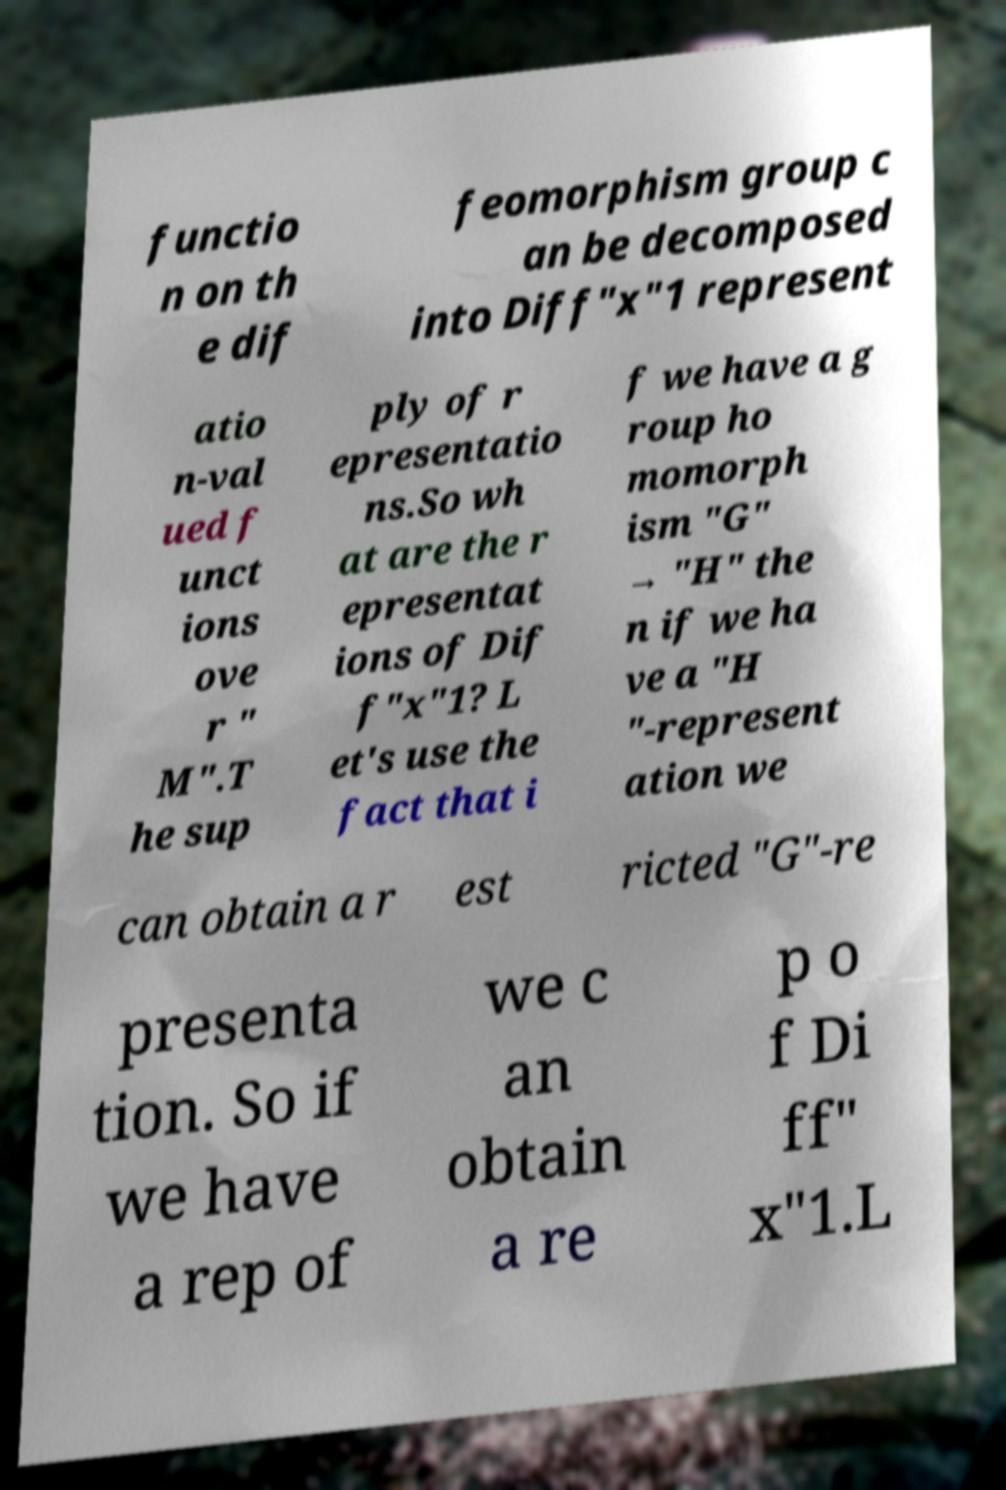Could you extract and type out the text from this image? functio n on th e dif feomorphism group c an be decomposed into Diff"x"1 represent atio n-val ued f unct ions ove r " M".T he sup ply of r epresentatio ns.So wh at are the r epresentat ions of Dif f"x"1? L et's use the fact that i f we have a g roup ho momorph ism "G" → "H" the n if we ha ve a "H "-represent ation we can obtain a r est ricted "G"-re presenta tion. So if we have a rep of we c an obtain a re p o f Di ff" x"1.L 